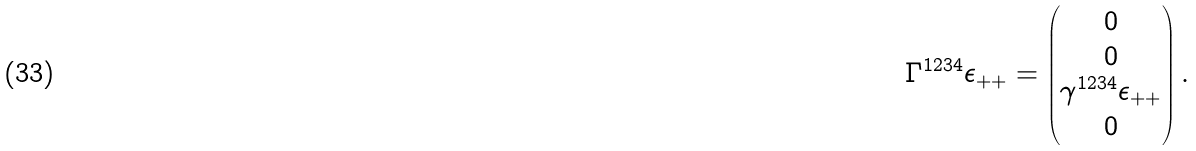<formula> <loc_0><loc_0><loc_500><loc_500>\Gamma ^ { 1 2 3 4 } \epsilon _ { + + } = \begin{pmatrix} 0 \\ 0 \\ \gamma ^ { 1 2 3 4 } \epsilon _ { + + } \\ 0 \end{pmatrix} .</formula> 